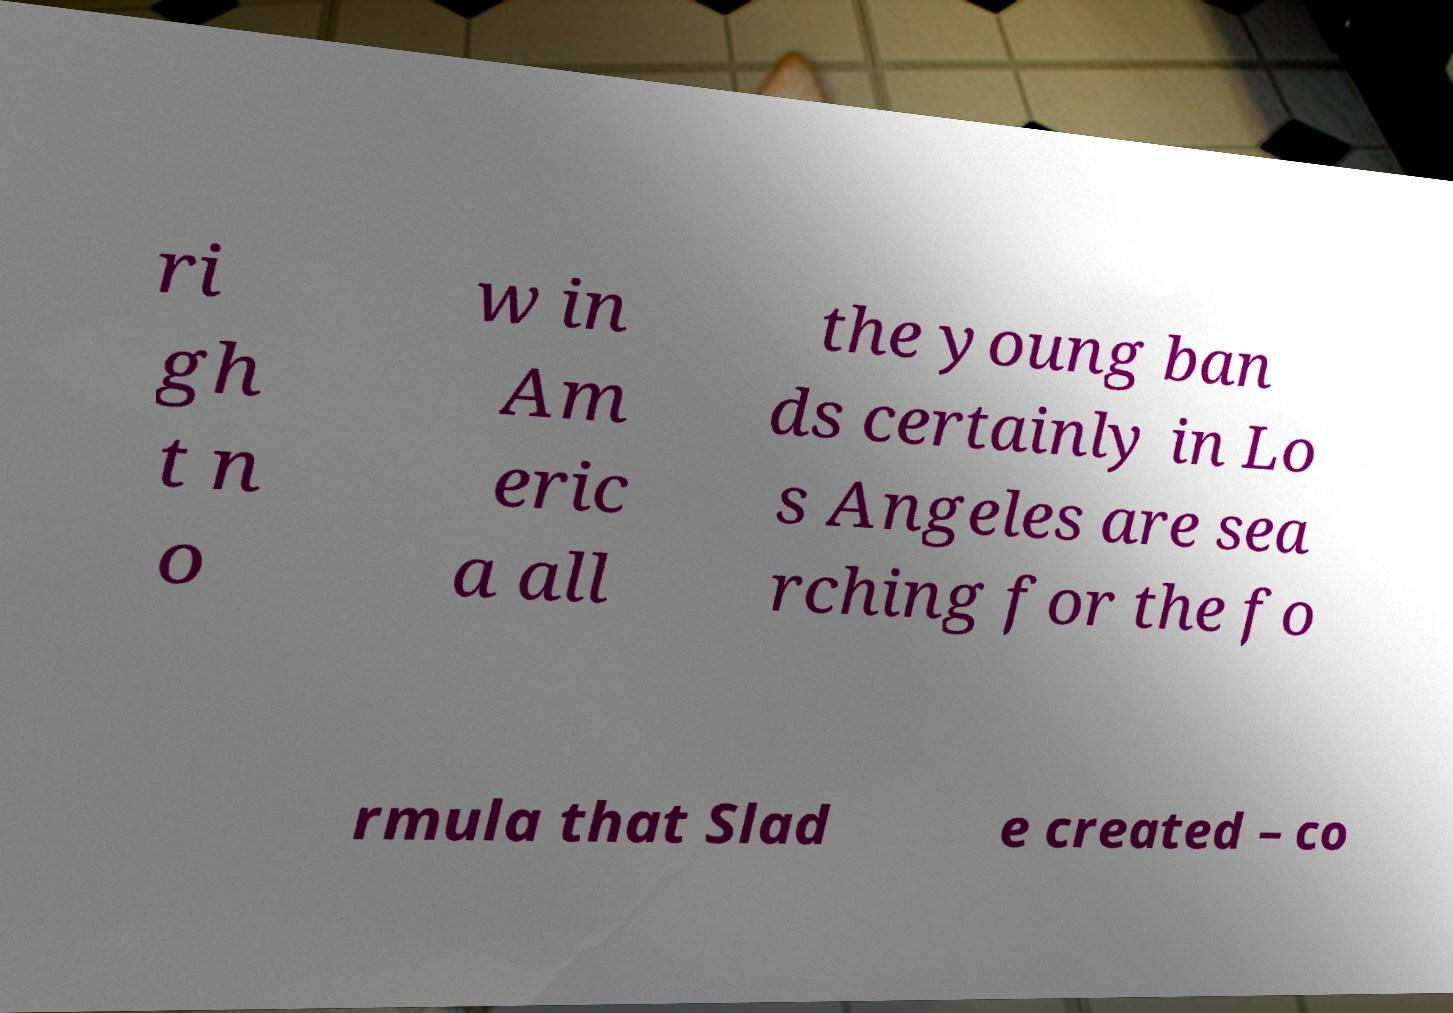Could you extract and type out the text from this image? ri gh t n o w in Am eric a all the young ban ds certainly in Lo s Angeles are sea rching for the fo rmula that Slad e created – co 